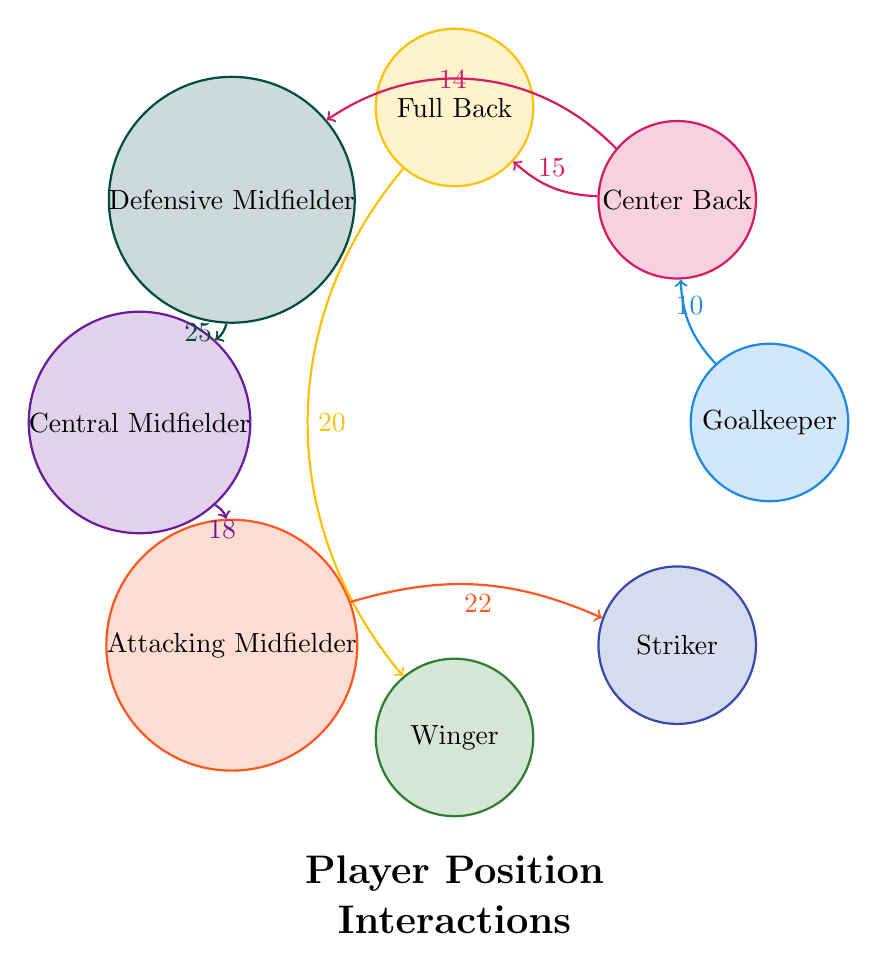What is the interaction value between the Goalkeeper and the Center Back? The interaction link from the Goalkeeper to the Center Back indicates a value of 10, as marked on the diagram.
Answer: 10 Which player interacts the most with the Winger? The Winger interacts with the Full Back with a value of 20, which is the highest among the connections linked to the Winger.
Answer: Full Back How many nodes are there in the diagram? The total number of nodes represented in the diagram is 8: Goalkeeper, Center Back, Full Back, Defensive Midfielder, Central Midfielder, Attacking Midfielder, Winger, and Striker.
Answer: 8 What is the total interaction value from the Central Midfielder to the Striker? The interaction value from the Central Midfielder to the Attacking Midfielder is 18, and from the Attacking Midfielder to the Striker is 22. Combining both interactions gives a total of 40.
Answer: 40 Which position has a direct connection to the most number of other positions? The Center Back directly connects to the Goalkeeper, Full Back, and Defensive Midfielder, making 3 direct connections in total.
Answer: Center Back What is the interaction value between the Defensive Midfielder and the Central Midfielder? The interaction value between the Defensive Midfielder and the Central Midfielder is indicated as 25 in the diagram.
Answer: 25 Which player has the highest outgoing interaction value? The Defensive Midfielder has the highest outgoing interaction value of 25, connecting to the Central Midfielder.
Answer: Defensive Midfielder What position is positioned opposite to the Striker in the diagram? The position opposite to the Striker in the circular arrangement of the diagram is the Goalkeeper.
Answer: Goalkeeper 